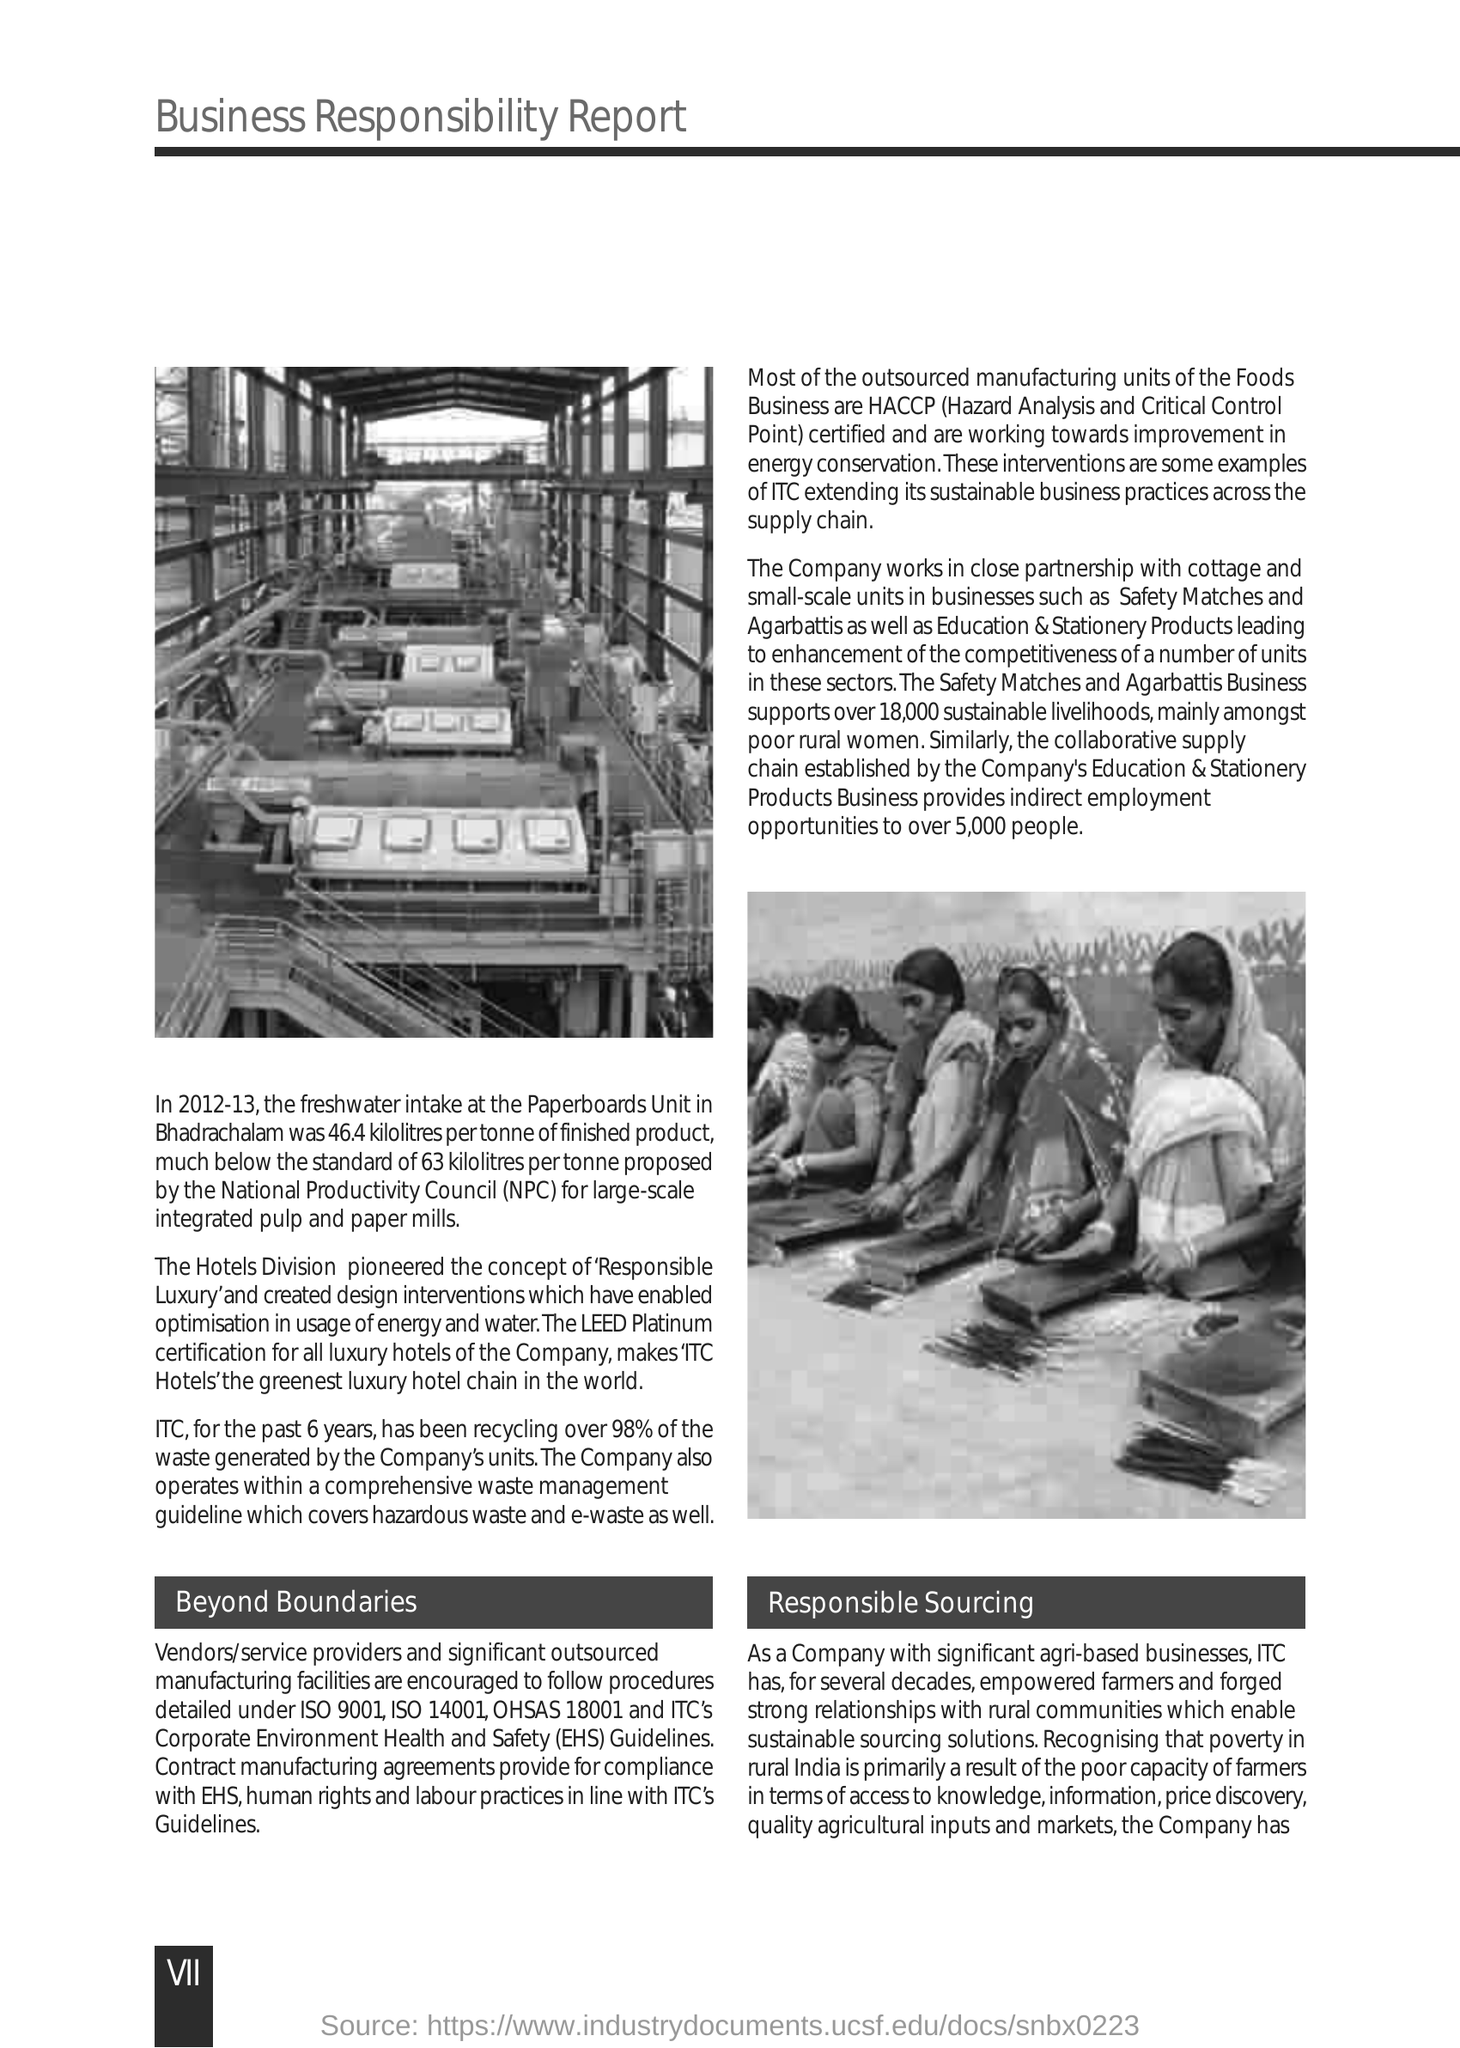Indicate a few pertinent items in this graphic. Over the past six years, ITC's recycling rate has consistently been 98%. 